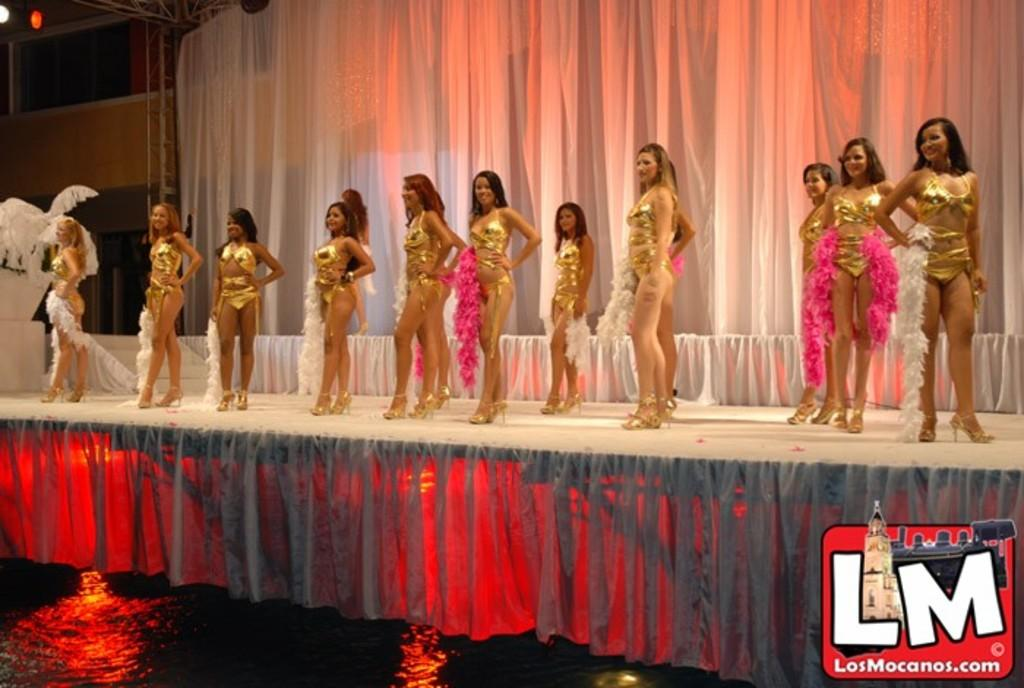Who is present in the image? There are women in the image. What are the women wearing? The women are wearing the same costume. Where are the women located in the image? The women are on a stage. What can be seen in the background of the image? There is a white curtain in the background of the image. What is present at the bottom of the image? There is a logo at the bottom of the image. What architectural feature is visible on the left side of the image? There are windows on the left side of the image. What type of substance is the women using to answer the questions in the image? There is no indication in the image that the women are answering any questions or using any substance to do so. 